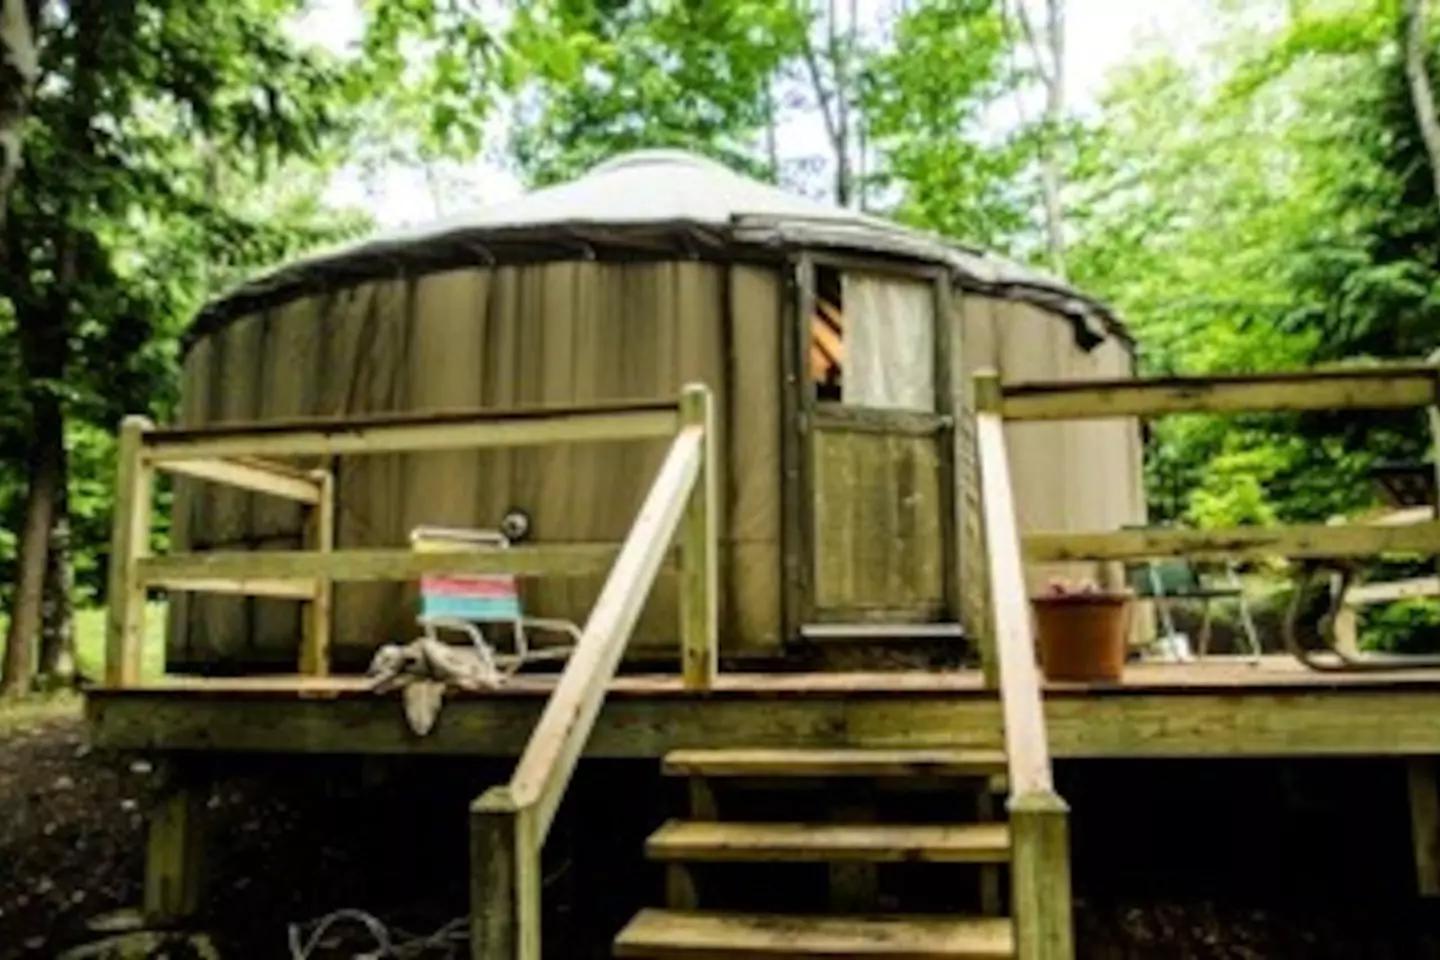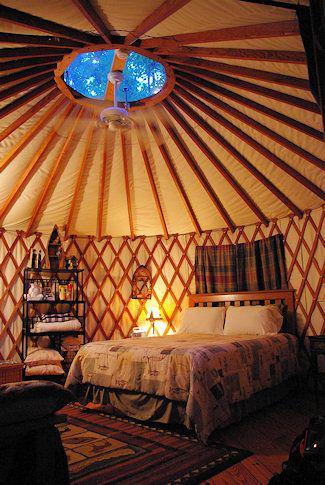The first image is the image on the left, the second image is the image on the right. Evaluate the accuracy of this statement regarding the images: "One of the images is of the outside of a yurt, and the other is of the inside, and there is no snow visible in either of them.". Is it true? Answer yes or no. Yes. The first image is the image on the left, the second image is the image on the right. For the images displayed, is the sentence "There are at least five items hanging in a line on the back wall." factually correct? Answer yes or no. No. 